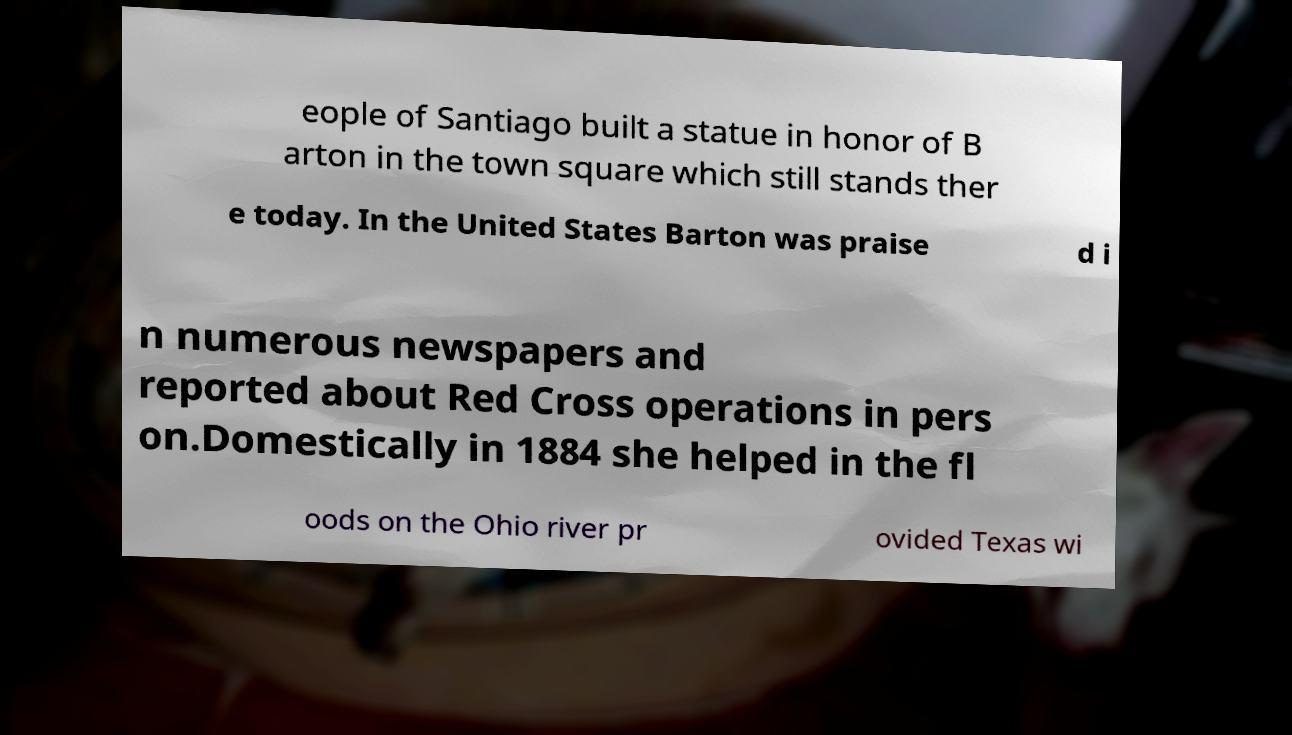Could you extract and type out the text from this image? eople of Santiago built a statue in honor of B arton in the town square which still stands ther e today. In the United States Barton was praise d i n numerous newspapers and reported about Red Cross operations in pers on.Domestically in 1884 she helped in the fl oods on the Ohio river pr ovided Texas wi 